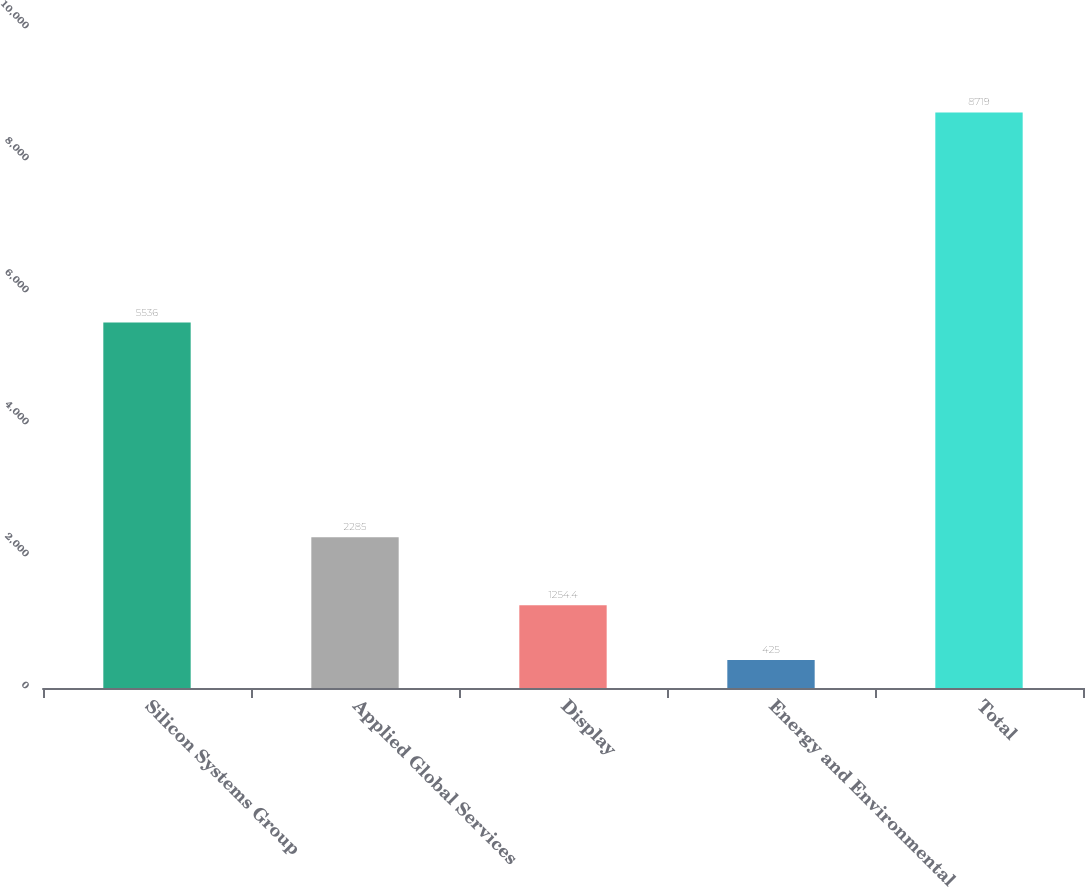Convert chart to OTSL. <chart><loc_0><loc_0><loc_500><loc_500><bar_chart><fcel>Silicon Systems Group<fcel>Applied Global Services<fcel>Display<fcel>Energy and Environmental<fcel>Total<nl><fcel>5536<fcel>2285<fcel>1254.4<fcel>425<fcel>8719<nl></chart> 